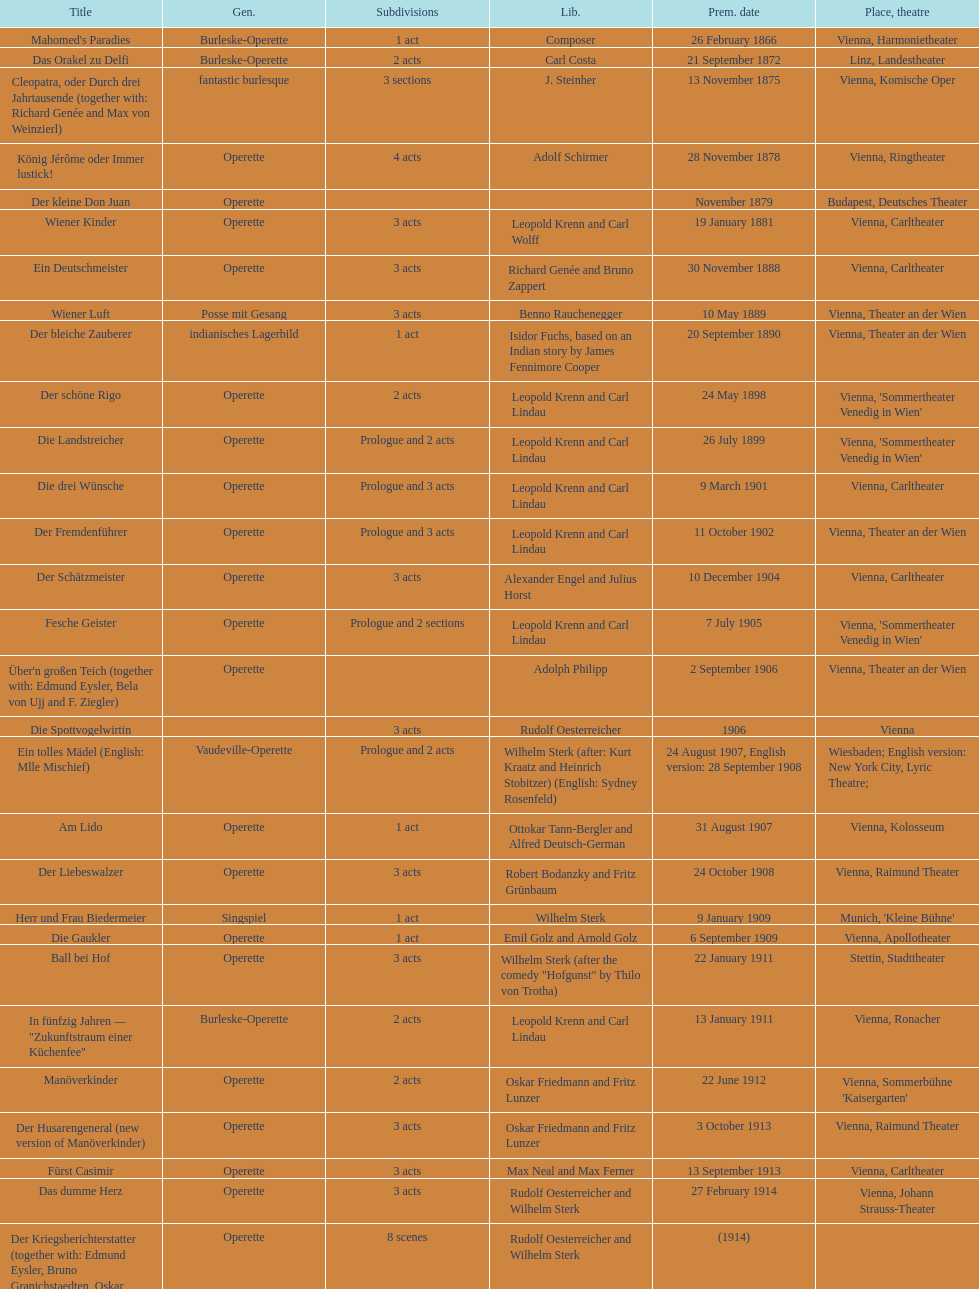What was the year of the last title? 1958. 